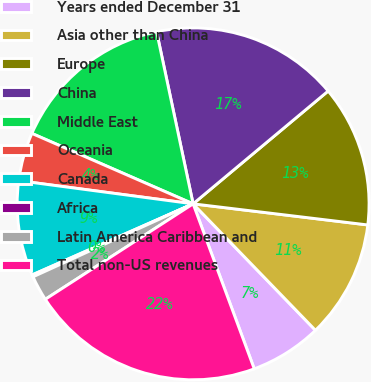Convert chart. <chart><loc_0><loc_0><loc_500><loc_500><pie_chart><fcel>Years ended December 31<fcel>Asia other than China<fcel>Europe<fcel>China<fcel>Middle East<fcel>Oceania<fcel>Canada<fcel>Africa<fcel>Latin America Caribbean and<fcel>Total non-US revenues<nl><fcel>6.59%<fcel>10.85%<fcel>12.99%<fcel>17.25%<fcel>15.12%<fcel>4.45%<fcel>8.72%<fcel>0.19%<fcel>2.32%<fcel>21.52%<nl></chart> 